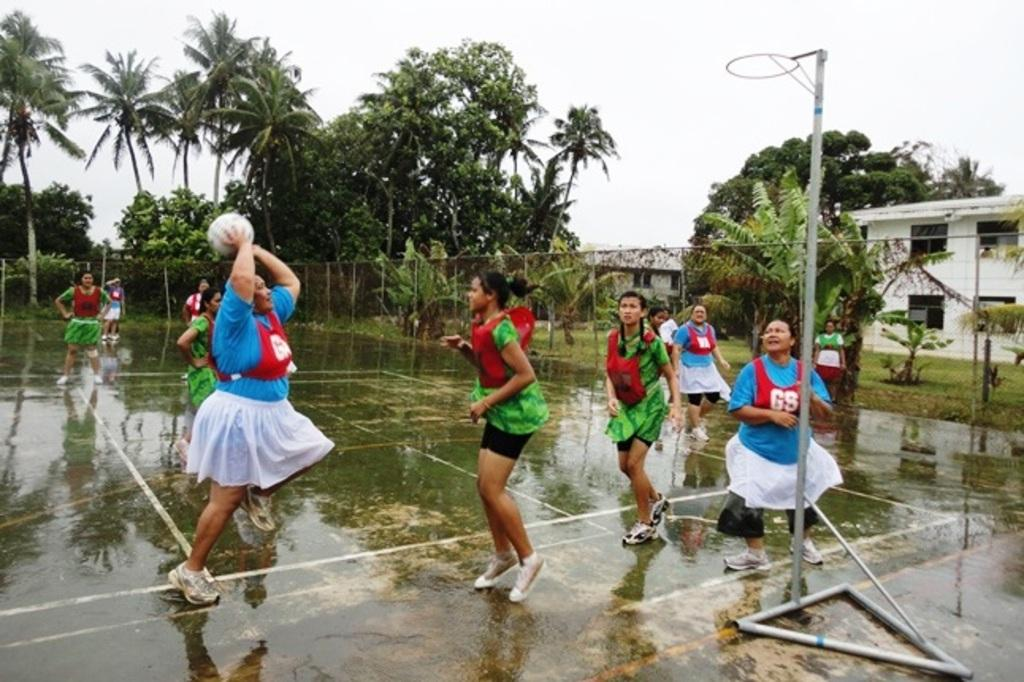What are the ladies in the image doing? The ladies in the image are playing a sport. What is at the bottom of the image? There is ground at the bottom of the image. What can be seen in the background of the image? There are trees, houses, and fencing in the background of the image. What type of tooth is visible on the line in the image? There is no tooth or line present in the image. How many pages are visible in the image? There are no pages present in the image. 